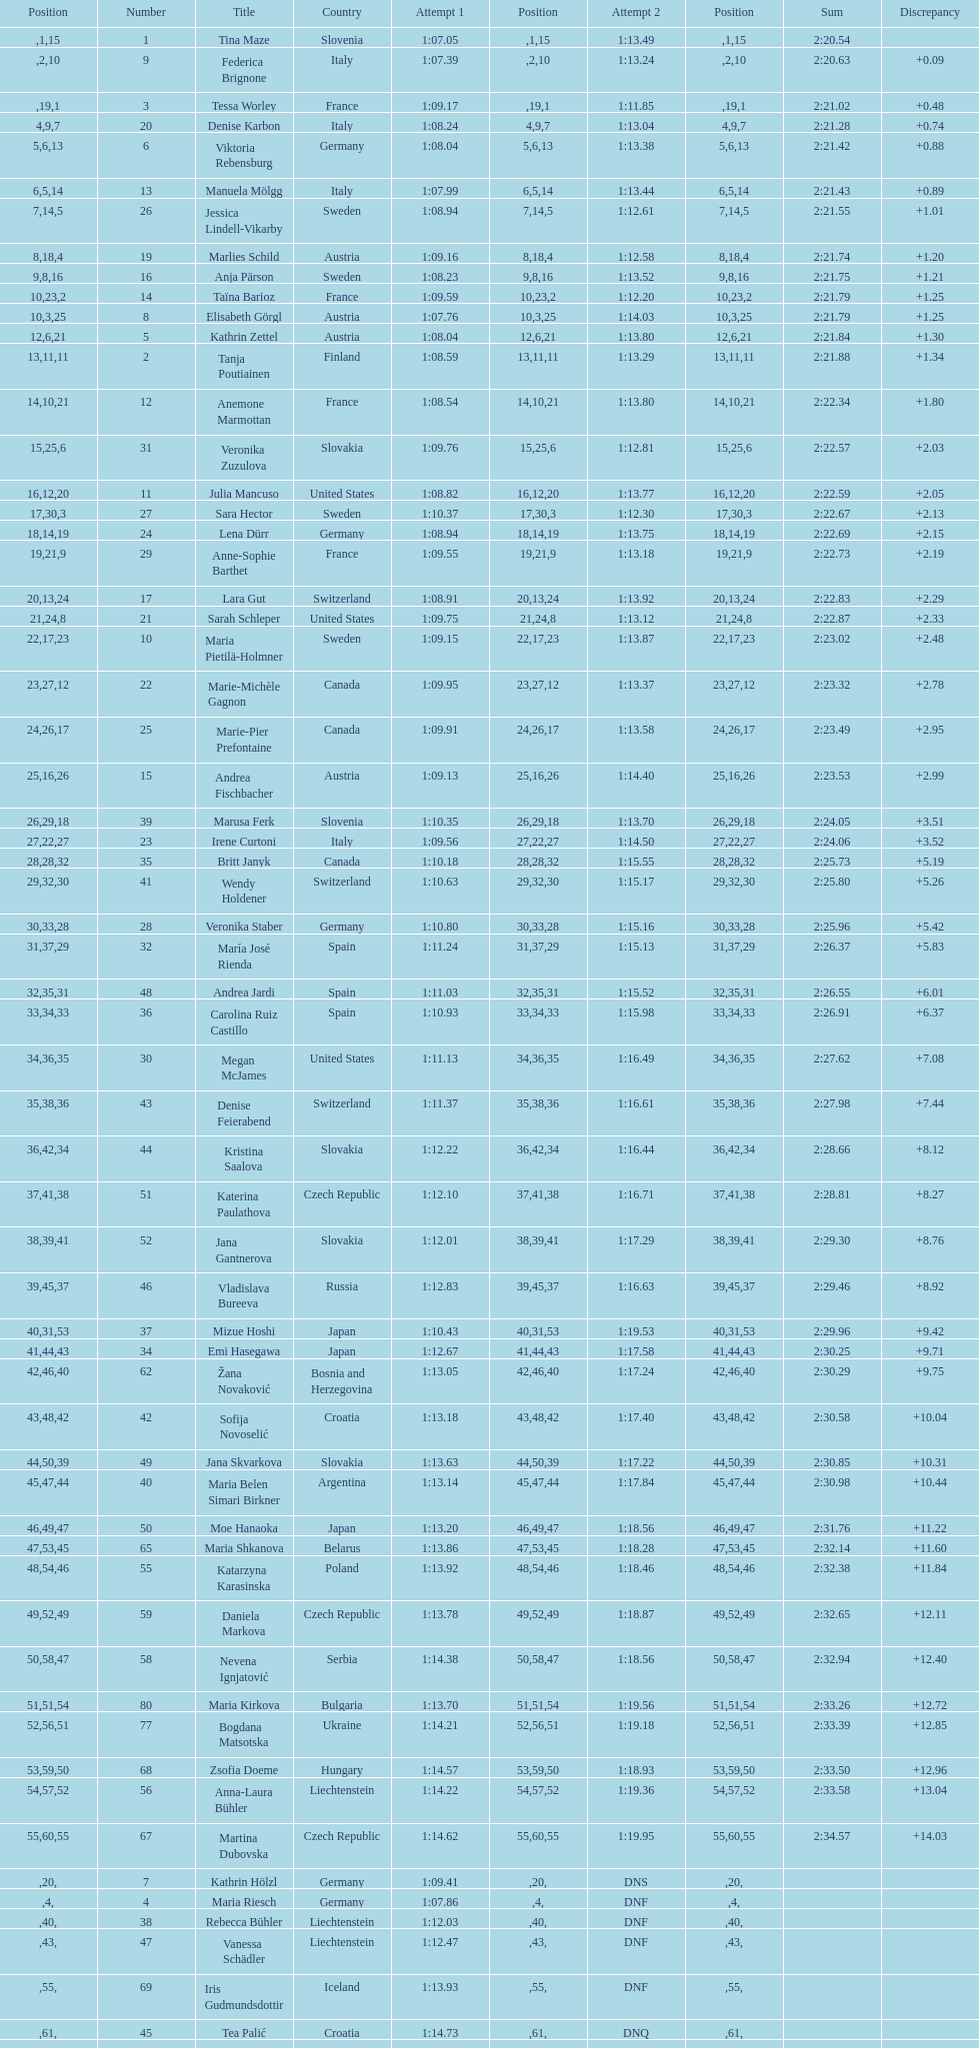How many athletes had the same rank for both run 1 and run 2? 1. 